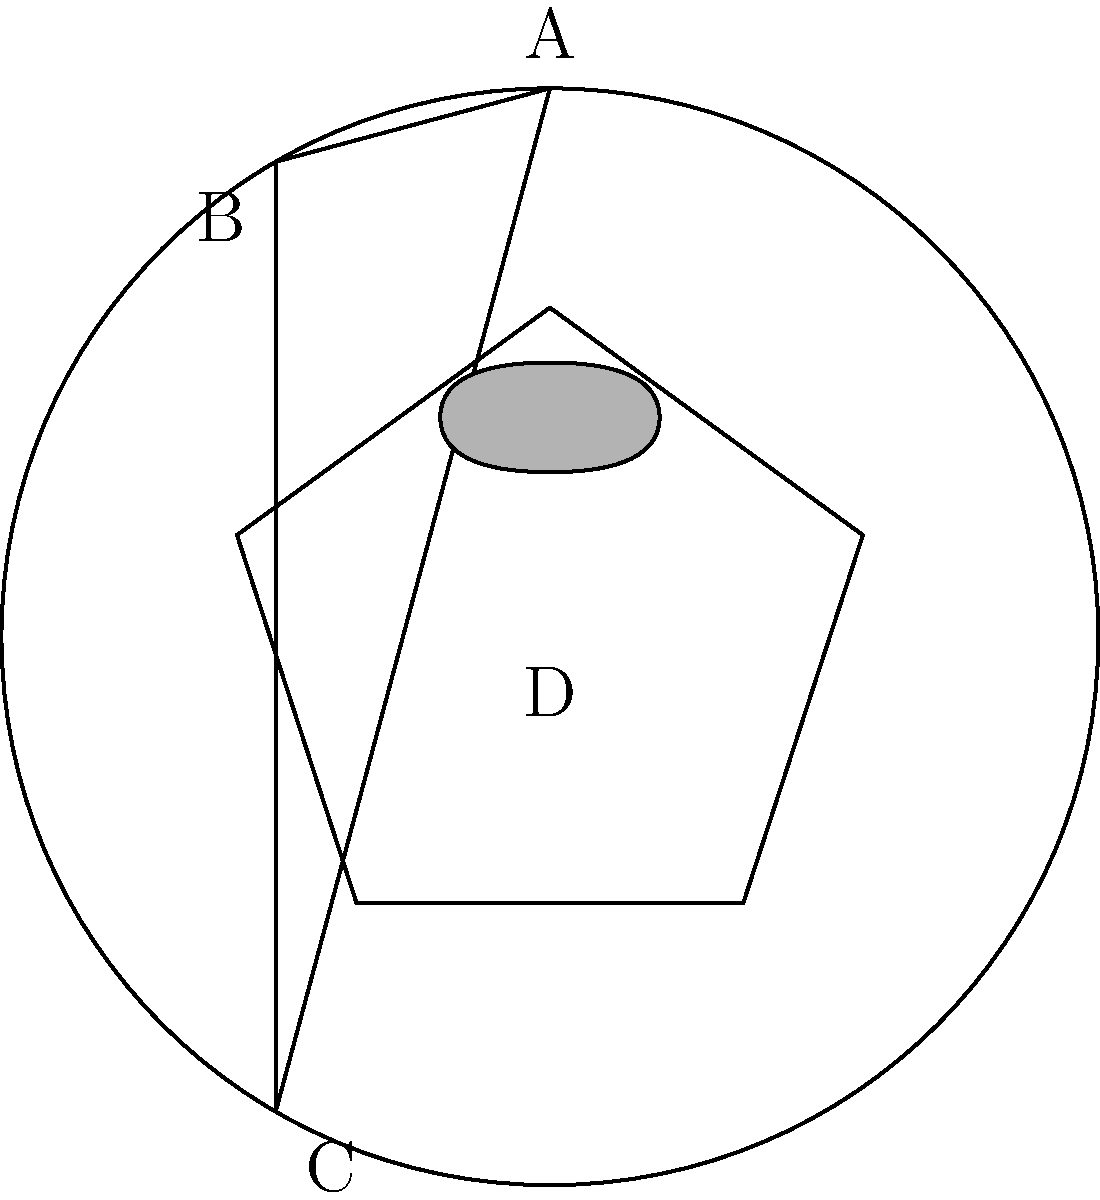In the given occult sigil composition, which element establishes the primary focal point and serves as the foundation for the overall visual hierarchy? To determine the primary focal point and foundation of the visual hierarchy in this occult sigil composition, we need to analyze the elements and their relationships:

1. Circle (outer boundary): The circle encompasses all other elements, providing a containing structure for the composition.

2. Triangle: Forms a large, prominent shape within the circle, connecting three points on the circle's circumference.

3. Pentagram: Positioned inside the triangle, creating a complex geometric pattern.

4. Eye symbol: Located near the center of the composition, small but symbolically significant.

Step-by-step analysis:

1. The circle serves as the outermost boundary, establishing the overall shape and containment of the sigil.

2. The triangle is the largest internal shape, creating strong visual lines and dividing the space into three sections.

3. The pentagram, while intricate, is smaller than the triangle and nested within it, suggesting a secondary level of importance.

4. The eye symbol, though centrally located, is the smallest element and lacks the bold lines of the other shapes.

In occult symbolism, the circle often represents unity, wholeness, and protection. It encompasses all other elements, providing a foundation for the entire composition. The triangle, pentagram, and eye symbol are all contained within and relate to this circular boundary.

Therefore, the circle establishes the primary focal point and serves as the foundation for the overall visual hierarchy in this occult sigil composition.
Answer: The circle 